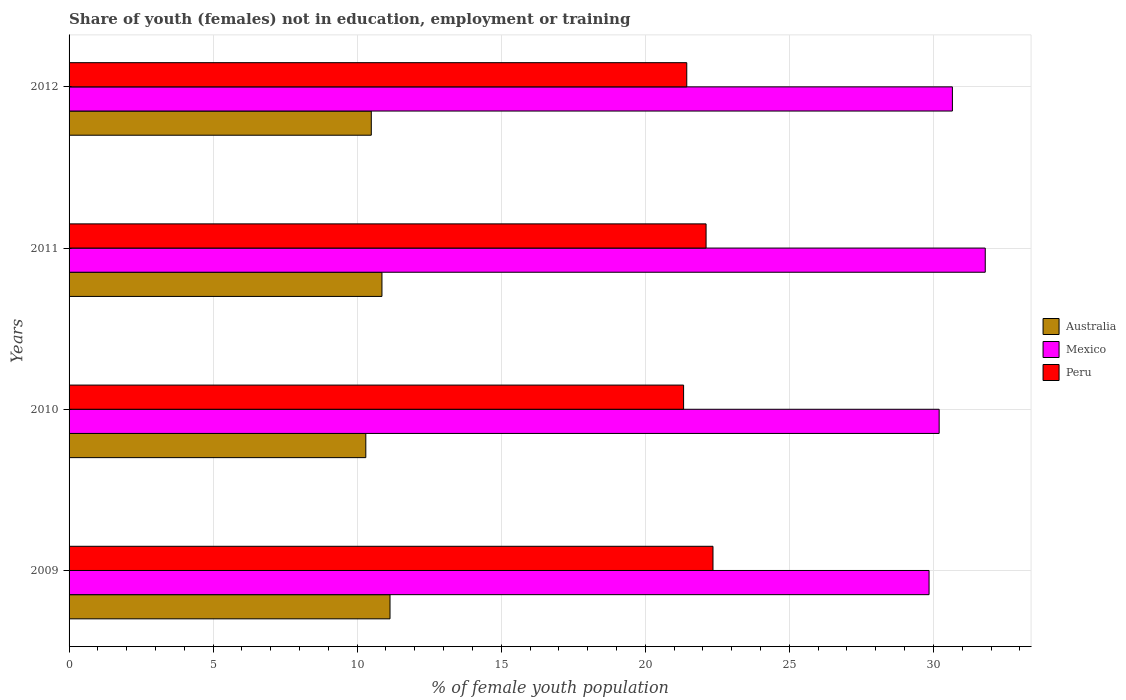How many different coloured bars are there?
Your answer should be compact. 3. Are the number of bars per tick equal to the number of legend labels?
Your response must be concise. Yes. Are the number of bars on each tick of the Y-axis equal?
Offer a very short reply. Yes. How many bars are there on the 2nd tick from the bottom?
Give a very brief answer. 3. What is the percentage of unemployed female population in in Mexico in 2011?
Give a very brief answer. 31.8. Across all years, what is the maximum percentage of unemployed female population in in Mexico?
Offer a terse response. 31.8. Across all years, what is the minimum percentage of unemployed female population in in Mexico?
Make the answer very short. 29.85. In which year was the percentage of unemployed female population in in Peru minimum?
Ensure brevity in your answer.  2010. What is the total percentage of unemployed female population in in Mexico in the graph?
Provide a succinct answer. 122.51. What is the difference between the percentage of unemployed female population in in Australia in 2009 and that in 2012?
Provide a succinct answer. 0.65. What is the difference between the percentage of unemployed female population in in Australia in 2011 and the percentage of unemployed female population in in Mexico in 2012?
Offer a very short reply. -19.8. What is the average percentage of unemployed female population in in Peru per year?
Your answer should be very brief. 21.81. In the year 2011, what is the difference between the percentage of unemployed female population in in Mexico and percentage of unemployed female population in in Peru?
Your answer should be compact. 9.69. What is the ratio of the percentage of unemployed female population in in Peru in 2009 to that in 2010?
Offer a terse response. 1.05. Is the percentage of unemployed female population in in Mexico in 2010 less than that in 2012?
Give a very brief answer. Yes. Is the difference between the percentage of unemployed female population in in Mexico in 2010 and 2012 greater than the difference between the percentage of unemployed female population in in Peru in 2010 and 2012?
Keep it short and to the point. No. What is the difference between the highest and the second highest percentage of unemployed female population in in Mexico?
Provide a short and direct response. 1.14. What is the difference between the highest and the lowest percentage of unemployed female population in in Mexico?
Offer a very short reply. 1.95. What does the 2nd bar from the top in 2011 represents?
Make the answer very short. Mexico. What does the 1st bar from the bottom in 2011 represents?
Provide a short and direct response. Australia. Are all the bars in the graph horizontal?
Your answer should be compact. Yes. What is the difference between two consecutive major ticks on the X-axis?
Ensure brevity in your answer.  5. Are the values on the major ticks of X-axis written in scientific E-notation?
Provide a short and direct response. No. Where does the legend appear in the graph?
Give a very brief answer. Center right. How many legend labels are there?
Your answer should be compact. 3. How are the legend labels stacked?
Ensure brevity in your answer.  Vertical. What is the title of the graph?
Your answer should be compact. Share of youth (females) not in education, employment or training. Does "Niger" appear as one of the legend labels in the graph?
Give a very brief answer. No. What is the label or title of the X-axis?
Make the answer very short. % of female youth population. What is the label or title of the Y-axis?
Your answer should be compact. Years. What is the % of female youth population of Australia in 2009?
Keep it short and to the point. 11.14. What is the % of female youth population in Mexico in 2009?
Offer a terse response. 29.85. What is the % of female youth population of Peru in 2009?
Keep it short and to the point. 22.35. What is the % of female youth population in Australia in 2010?
Provide a succinct answer. 10.3. What is the % of female youth population of Mexico in 2010?
Provide a succinct answer. 30.2. What is the % of female youth population of Peru in 2010?
Offer a very short reply. 21.33. What is the % of female youth population of Australia in 2011?
Provide a succinct answer. 10.86. What is the % of female youth population of Mexico in 2011?
Offer a terse response. 31.8. What is the % of female youth population in Peru in 2011?
Provide a short and direct response. 22.11. What is the % of female youth population in Australia in 2012?
Provide a succinct answer. 10.49. What is the % of female youth population in Mexico in 2012?
Provide a succinct answer. 30.66. What is the % of female youth population of Peru in 2012?
Ensure brevity in your answer.  21.44. Across all years, what is the maximum % of female youth population in Australia?
Your answer should be very brief. 11.14. Across all years, what is the maximum % of female youth population of Mexico?
Ensure brevity in your answer.  31.8. Across all years, what is the maximum % of female youth population in Peru?
Offer a terse response. 22.35. Across all years, what is the minimum % of female youth population in Australia?
Your response must be concise. 10.3. Across all years, what is the minimum % of female youth population of Mexico?
Your answer should be compact. 29.85. Across all years, what is the minimum % of female youth population in Peru?
Make the answer very short. 21.33. What is the total % of female youth population of Australia in the graph?
Your answer should be compact. 42.79. What is the total % of female youth population in Mexico in the graph?
Give a very brief answer. 122.51. What is the total % of female youth population in Peru in the graph?
Ensure brevity in your answer.  87.23. What is the difference between the % of female youth population of Australia in 2009 and that in 2010?
Provide a succinct answer. 0.84. What is the difference between the % of female youth population of Mexico in 2009 and that in 2010?
Your response must be concise. -0.35. What is the difference between the % of female youth population in Australia in 2009 and that in 2011?
Keep it short and to the point. 0.28. What is the difference between the % of female youth population of Mexico in 2009 and that in 2011?
Offer a very short reply. -1.95. What is the difference between the % of female youth population in Peru in 2009 and that in 2011?
Your answer should be very brief. 0.24. What is the difference between the % of female youth population in Australia in 2009 and that in 2012?
Offer a very short reply. 0.65. What is the difference between the % of female youth population in Mexico in 2009 and that in 2012?
Offer a very short reply. -0.81. What is the difference between the % of female youth population of Peru in 2009 and that in 2012?
Keep it short and to the point. 0.91. What is the difference between the % of female youth population of Australia in 2010 and that in 2011?
Your answer should be very brief. -0.56. What is the difference between the % of female youth population of Mexico in 2010 and that in 2011?
Your answer should be compact. -1.6. What is the difference between the % of female youth population of Peru in 2010 and that in 2011?
Keep it short and to the point. -0.78. What is the difference between the % of female youth population in Australia in 2010 and that in 2012?
Offer a very short reply. -0.19. What is the difference between the % of female youth population of Mexico in 2010 and that in 2012?
Provide a succinct answer. -0.46. What is the difference between the % of female youth population of Peru in 2010 and that in 2012?
Your answer should be compact. -0.11. What is the difference between the % of female youth population of Australia in 2011 and that in 2012?
Your answer should be compact. 0.37. What is the difference between the % of female youth population of Mexico in 2011 and that in 2012?
Offer a terse response. 1.14. What is the difference between the % of female youth population of Peru in 2011 and that in 2012?
Your answer should be very brief. 0.67. What is the difference between the % of female youth population in Australia in 2009 and the % of female youth population in Mexico in 2010?
Ensure brevity in your answer.  -19.06. What is the difference between the % of female youth population of Australia in 2009 and the % of female youth population of Peru in 2010?
Your response must be concise. -10.19. What is the difference between the % of female youth population of Mexico in 2009 and the % of female youth population of Peru in 2010?
Offer a terse response. 8.52. What is the difference between the % of female youth population of Australia in 2009 and the % of female youth population of Mexico in 2011?
Provide a short and direct response. -20.66. What is the difference between the % of female youth population of Australia in 2009 and the % of female youth population of Peru in 2011?
Provide a short and direct response. -10.97. What is the difference between the % of female youth population in Mexico in 2009 and the % of female youth population in Peru in 2011?
Make the answer very short. 7.74. What is the difference between the % of female youth population in Australia in 2009 and the % of female youth population in Mexico in 2012?
Make the answer very short. -19.52. What is the difference between the % of female youth population of Mexico in 2009 and the % of female youth population of Peru in 2012?
Make the answer very short. 8.41. What is the difference between the % of female youth population in Australia in 2010 and the % of female youth population in Mexico in 2011?
Offer a terse response. -21.5. What is the difference between the % of female youth population in Australia in 2010 and the % of female youth population in Peru in 2011?
Make the answer very short. -11.81. What is the difference between the % of female youth population in Mexico in 2010 and the % of female youth population in Peru in 2011?
Your answer should be compact. 8.09. What is the difference between the % of female youth population in Australia in 2010 and the % of female youth population in Mexico in 2012?
Your answer should be compact. -20.36. What is the difference between the % of female youth population in Australia in 2010 and the % of female youth population in Peru in 2012?
Offer a terse response. -11.14. What is the difference between the % of female youth population in Mexico in 2010 and the % of female youth population in Peru in 2012?
Your answer should be compact. 8.76. What is the difference between the % of female youth population of Australia in 2011 and the % of female youth population of Mexico in 2012?
Keep it short and to the point. -19.8. What is the difference between the % of female youth population of Australia in 2011 and the % of female youth population of Peru in 2012?
Provide a succinct answer. -10.58. What is the difference between the % of female youth population of Mexico in 2011 and the % of female youth population of Peru in 2012?
Keep it short and to the point. 10.36. What is the average % of female youth population in Australia per year?
Keep it short and to the point. 10.7. What is the average % of female youth population in Mexico per year?
Keep it short and to the point. 30.63. What is the average % of female youth population of Peru per year?
Ensure brevity in your answer.  21.81. In the year 2009, what is the difference between the % of female youth population in Australia and % of female youth population in Mexico?
Ensure brevity in your answer.  -18.71. In the year 2009, what is the difference between the % of female youth population of Australia and % of female youth population of Peru?
Provide a short and direct response. -11.21. In the year 2009, what is the difference between the % of female youth population of Mexico and % of female youth population of Peru?
Keep it short and to the point. 7.5. In the year 2010, what is the difference between the % of female youth population in Australia and % of female youth population in Mexico?
Ensure brevity in your answer.  -19.9. In the year 2010, what is the difference between the % of female youth population in Australia and % of female youth population in Peru?
Offer a terse response. -11.03. In the year 2010, what is the difference between the % of female youth population of Mexico and % of female youth population of Peru?
Ensure brevity in your answer.  8.87. In the year 2011, what is the difference between the % of female youth population of Australia and % of female youth population of Mexico?
Your answer should be very brief. -20.94. In the year 2011, what is the difference between the % of female youth population in Australia and % of female youth population in Peru?
Your response must be concise. -11.25. In the year 2011, what is the difference between the % of female youth population in Mexico and % of female youth population in Peru?
Keep it short and to the point. 9.69. In the year 2012, what is the difference between the % of female youth population in Australia and % of female youth population in Mexico?
Ensure brevity in your answer.  -20.17. In the year 2012, what is the difference between the % of female youth population of Australia and % of female youth population of Peru?
Your answer should be very brief. -10.95. In the year 2012, what is the difference between the % of female youth population in Mexico and % of female youth population in Peru?
Keep it short and to the point. 9.22. What is the ratio of the % of female youth population in Australia in 2009 to that in 2010?
Provide a short and direct response. 1.08. What is the ratio of the % of female youth population of Mexico in 2009 to that in 2010?
Make the answer very short. 0.99. What is the ratio of the % of female youth population of Peru in 2009 to that in 2010?
Keep it short and to the point. 1.05. What is the ratio of the % of female youth population in Australia in 2009 to that in 2011?
Offer a terse response. 1.03. What is the ratio of the % of female youth population in Mexico in 2009 to that in 2011?
Offer a terse response. 0.94. What is the ratio of the % of female youth population of Peru in 2009 to that in 2011?
Your response must be concise. 1.01. What is the ratio of the % of female youth population in Australia in 2009 to that in 2012?
Offer a very short reply. 1.06. What is the ratio of the % of female youth population in Mexico in 2009 to that in 2012?
Provide a succinct answer. 0.97. What is the ratio of the % of female youth population of Peru in 2009 to that in 2012?
Offer a very short reply. 1.04. What is the ratio of the % of female youth population in Australia in 2010 to that in 2011?
Make the answer very short. 0.95. What is the ratio of the % of female youth population of Mexico in 2010 to that in 2011?
Offer a very short reply. 0.95. What is the ratio of the % of female youth population in Peru in 2010 to that in 2011?
Provide a succinct answer. 0.96. What is the ratio of the % of female youth population in Australia in 2010 to that in 2012?
Your response must be concise. 0.98. What is the ratio of the % of female youth population in Australia in 2011 to that in 2012?
Offer a very short reply. 1.04. What is the ratio of the % of female youth population in Mexico in 2011 to that in 2012?
Offer a terse response. 1.04. What is the ratio of the % of female youth population in Peru in 2011 to that in 2012?
Provide a short and direct response. 1.03. What is the difference between the highest and the second highest % of female youth population in Australia?
Provide a short and direct response. 0.28. What is the difference between the highest and the second highest % of female youth population in Mexico?
Keep it short and to the point. 1.14. What is the difference between the highest and the second highest % of female youth population in Peru?
Keep it short and to the point. 0.24. What is the difference between the highest and the lowest % of female youth population of Australia?
Your response must be concise. 0.84. What is the difference between the highest and the lowest % of female youth population of Mexico?
Your answer should be compact. 1.95. 